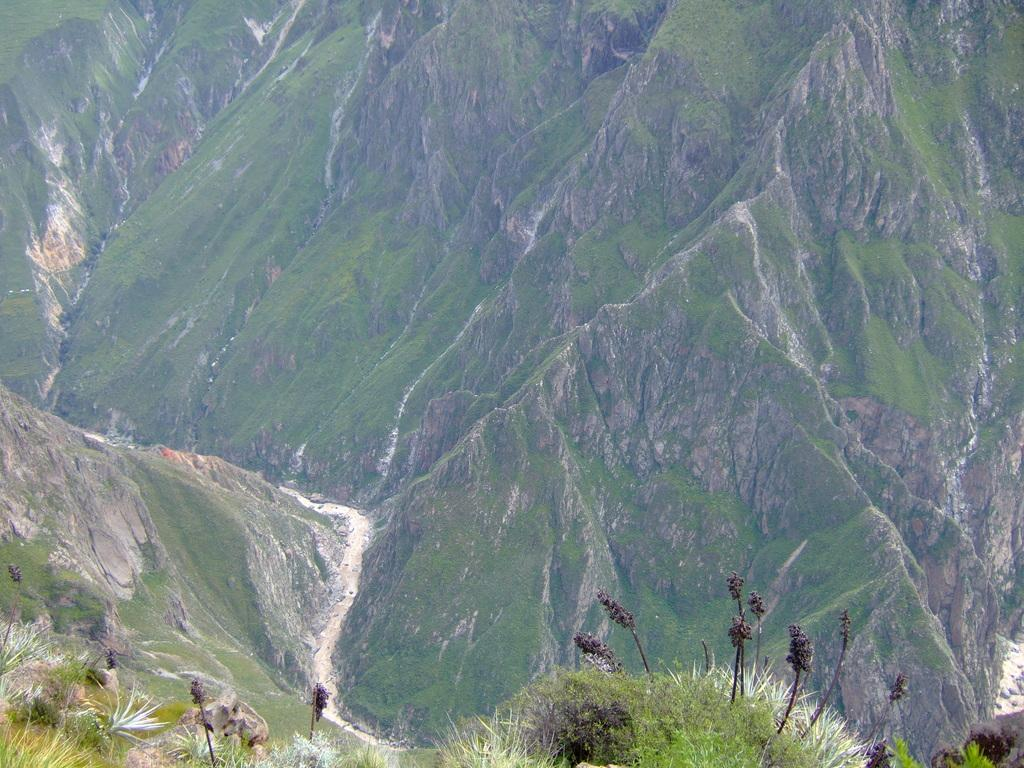What type of living organisms can be seen in the image? Plants can be seen in the image. What can be seen in the background of the image? Hills are visible in the background of the image. How are the hills covered? The hills are covered with trees. What type of shoe is being twisted on the hill in the image? There is no shoe present in the image, and no twisting is taking place. 